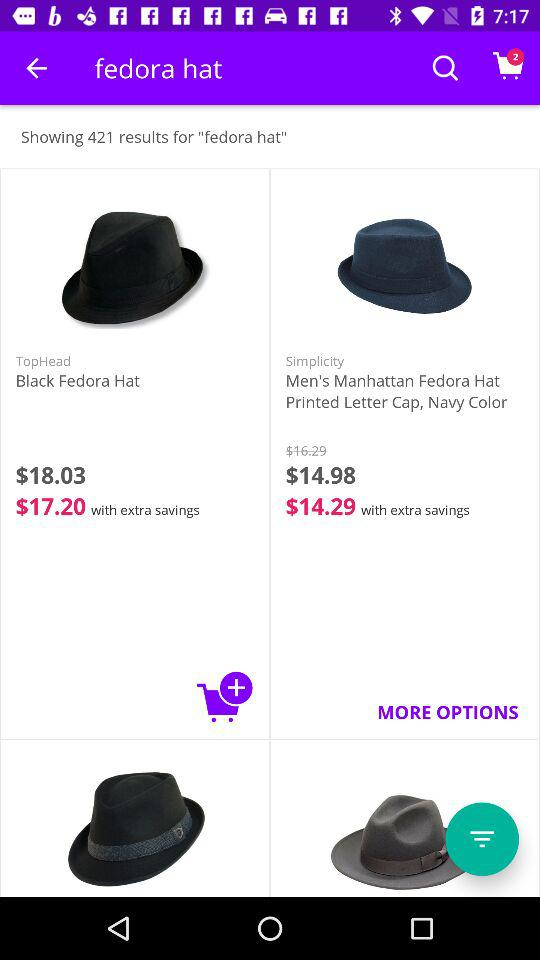How many results are shown for "fedora hat"? There are 421 results shown for "fedora hat". 